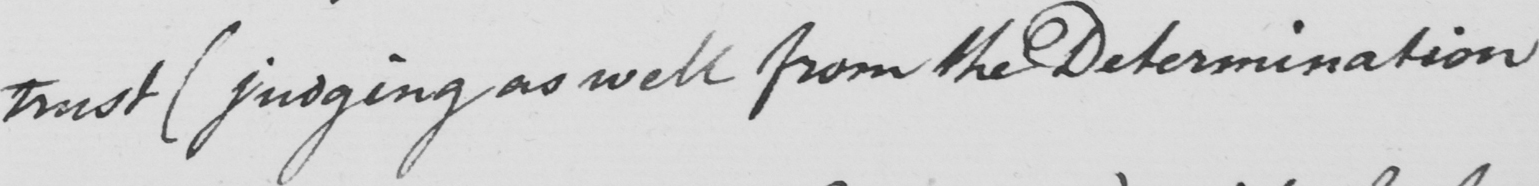Transcribe the text shown in this historical manuscript line. trust  ( judging as well from the Determination 